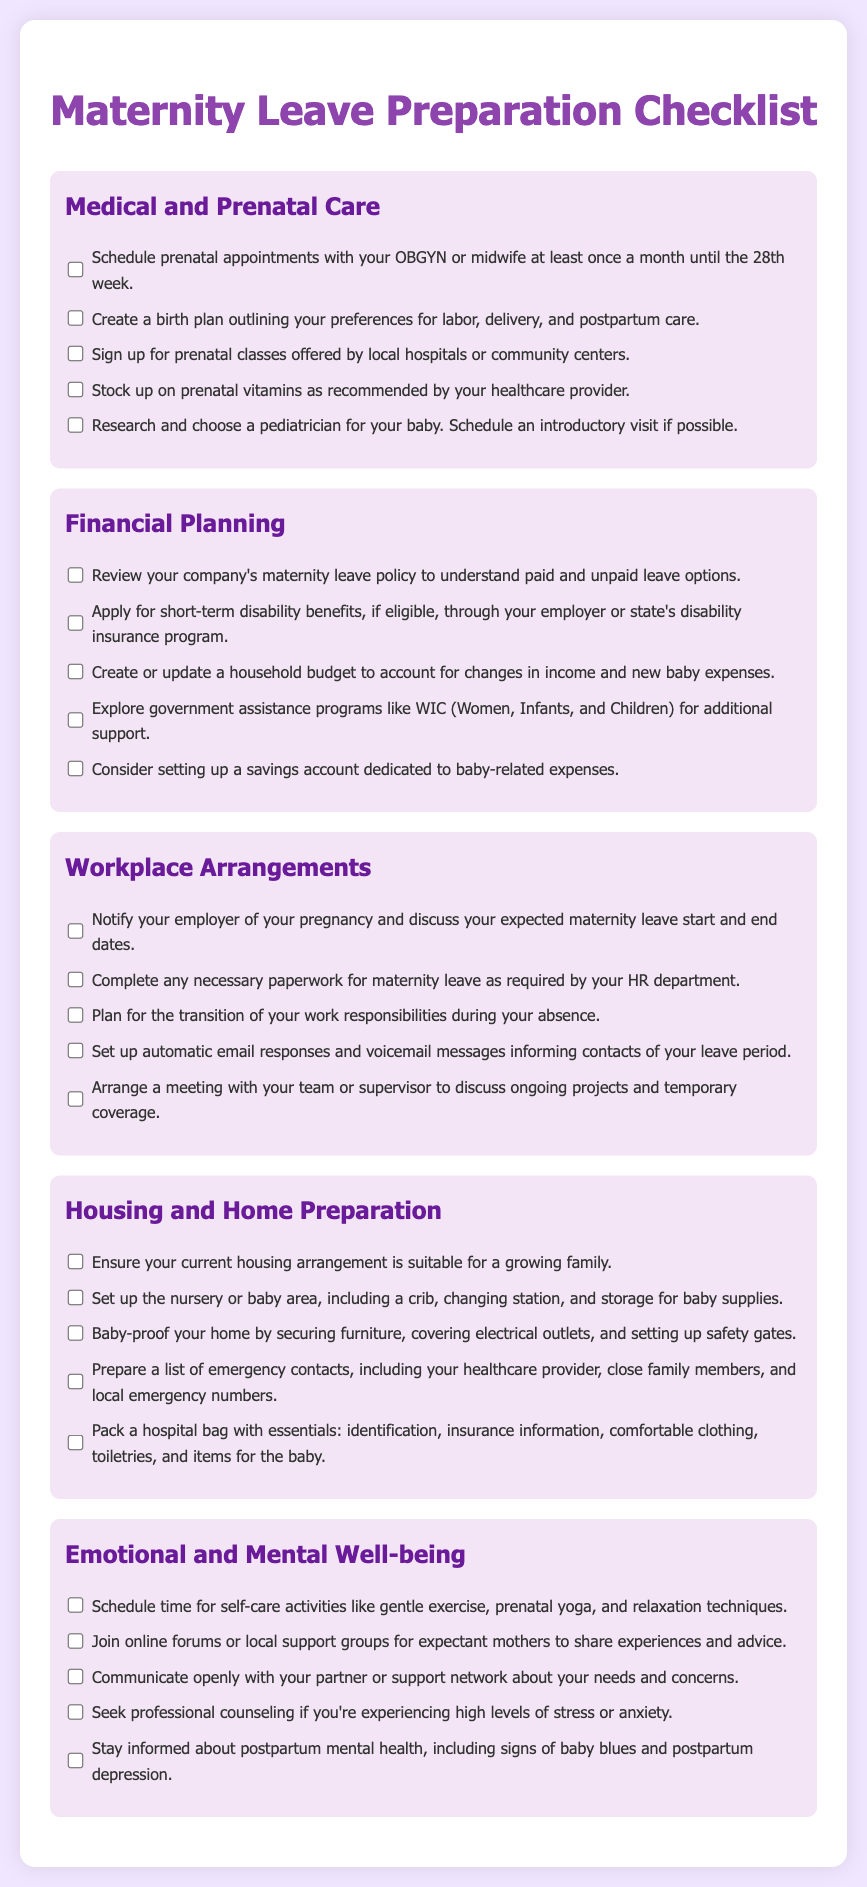what is the title of the document? The title of the document is presented in the header section as "Maternity Leave Preparation Checklist."
Answer: Maternity Leave Preparation Checklist how many categories are there in the checklist? The checklist has five categories that cover different aspects of maternity leave preparation.
Answer: five what is the first task listed under Medical and Prenatal Care? The first task in the Medical and Prenatal Care section is to schedule prenatal appointments with your OBGYN or midwife.
Answer: Schedule prenatal appointments what is one way to support financial planning listed in the document? One way to support financial planning mentioned is to explore government assistance programs like WIC.
Answer: Explore government assistance programs what is a suggested activity for emotional and mental well-being? The document suggests scheduling time for self-care activities like gentle exercise or prenatal yoga.
Answer: Schedule time for self-care activities what should you prepare for in the Housing and Home Preparation category? In the Housing and Home Preparation category, you should prepare a list of emergency contacts, including your healthcare provider.
Answer: Prepare a list of emergency contacts what is one method to notify your employer of your pregnancy? One method to notify your employer is to discuss your expected maternity leave start and end dates.
Answer: Discuss expected maternity leave dates how often should prenatal appointments be scheduled until the 28th week? Prenatal appointments should be scheduled at least once a month until the 28th week.
Answer: once a month 